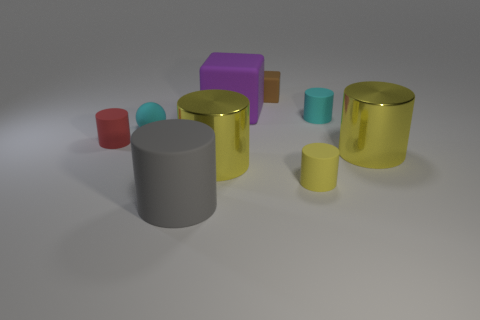Is the material of the large thing behind the tiny sphere the same as the big yellow cylinder to the left of the brown matte block?
Make the answer very short. No. How many balls are right of the gray cylinder?
Provide a short and direct response. 0. How many blue things are either large shiny cylinders or tiny things?
Your answer should be compact. 0. There is a brown thing that is the same size as the red cylinder; what is it made of?
Your answer should be compact. Rubber. What is the shape of the rubber object that is both in front of the cyan matte ball and on the right side of the gray cylinder?
Offer a terse response. Cylinder. What is the color of the other rubber thing that is the same size as the gray matte object?
Offer a very short reply. Purple. There is a rubber cylinder left of the big matte cylinder; is it the same size as the cube that is in front of the brown matte block?
Your response must be concise. No. What size is the yellow metallic thing on the right side of the small cylinder that is in front of the yellow cylinder that is to the right of the yellow rubber thing?
Keep it short and to the point. Large. There is a large thing that is behind the big yellow shiny cylinder to the right of the big purple block; what is its shape?
Provide a succinct answer. Cube. There is a metal thing to the right of the small brown rubber block; is its color the same as the large rubber cylinder?
Keep it short and to the point. No. 